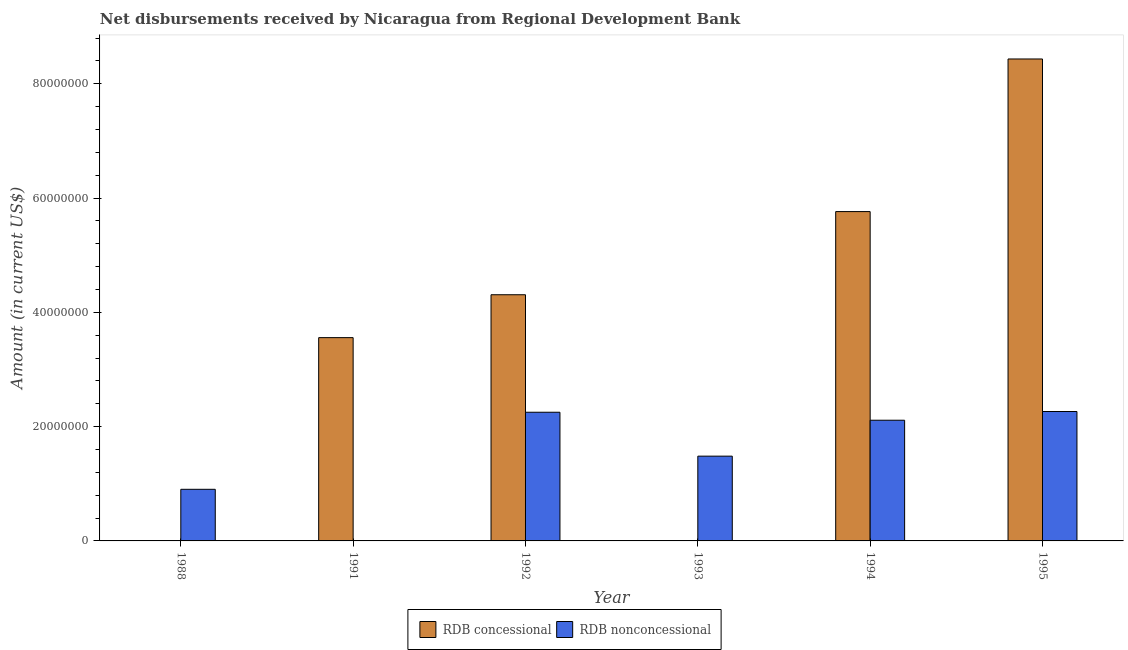How many different coloured bars are there?
Offer a very short reply. 2. Are the number of bars per tick equal to the number of legend labels?
Provide a succinct answer. No. Are the number of bars on each tick of the X-axis equal?
Your answer should be very brief. No. What is the label of the 5th group of bars from the left?
Keep it short and to the point. 1994. What is the net non concessional disbursements from rdb in 1993?
Keep it short and to the point. 1.48e+07. Across all years, what is the maximum net concessional disbursements from rdb?
Your answer should be very brief. 8.43e+07. In which year was the net non concessional disbursements from rdb maximum?
Offer a very short reply. 1995. What is the total net non concessional disbursements from rdb in the graph?
Give a very brief answer. 9.02e+07. What is the difference between the net non concessional disbursements from rdb in 1994 and that in 1995?
Give a very brief answer. -1.53e+06. What is the difference between the net non concessional disbursements from rdb in 1993 and the net concessional disbursements from rdb in 1992?
Give a very brief answer. -7.68e+06. What is the average net concessional disbursements from rdb per year?
Your response must be concise. 3.68e+07. In the year 1993, what is the difference between the net non concessional disbursements from rdb and net concessional disbursements from rdb?
Your answer should be compact. 0. What is the ratio of the net concessional disbursements from rdb in 1992 to that in 1995?
Provide a succinct answer. 0.51. Is the net non concessional disbursements from rdb in 1988 less than that in 1993?
Make the answer very short. Yes. What is the difference between the highest and the second highest net concessional disbursements from rdb?
Ensure brevity in your answer.  2.67e+07. What is the difference between the highest and the lowest net concessional disbursements from rdb?
Provide a short and direct response. 8.43e+07. In how many years, is the net non concessional disbursements from rdb greater than the average net non concessional disbursements from rdb taken over all years?
Make the answer very short. 3. How many bars are there?
Ensure brevity in your answer.  9. What is the difference between two consecutive major ticks on the Y-axis?
Ensure brevity in your answer.  2.00e+07. Are the values on the major ticks of Y-axis written in scientific E-notation?
Your answer should be very brief. No. Does the graph contain grids?
Your answer should be very brief. No. Where does the legend appear in the graph?
Offer a terse response. Bottom center. How are the legend labels stacked?
Make the answer very short. Horizontal. What is the title of the graph?
Make the answer very short. Net disbursements received by Nicaragua from Regional Development Bank. What is the label or title of the X-axis?
Provide a short and direct response. Year. What is the label or title of the Y-axis?
Your answer should be very brief. Amount (in current US$). What is the Amount (in current US$) of RDB concessional in 1988?
Ensure brevity in your answer.  0. What is the Amount (in current US$) of RDB nonconcessional in 1988?
Provide a succinct answer. 9.03e+06. What is the Amount (in current US$) in RDB concessional in 1991?
Give a very brief answer. 3.56e+07. What is the Amount (in current US$) of RDB nonconcessional in 1991?
Your answer should be compact. 0. What is the Amount (in current US$) of RDB concessional in 1992?
Your response must be concise. 4.31e+07. What is the Amount (in current US$) in RDB nonconcessional in 1992?
Your response must be concise. 2.25e+07. What is the Amount (in current US$) in RDB concessional in 1993?
Offer a very short reply. 0. What is the Amount (in current US$) in RDB nonconcessional in 1993?
Provide a succinct answer. 1.48e+07. What is the Amount (in current US$) of RDB concessional in 1994?
Provide a short and direct response. 5.76e+07. What is the Amount (in current US$) of RDB nonconcessional in 1994?
Your answer should be very brief. 2.11e+07. What is the Amount (in current US$) in RDB concessional in 1995?
Offer a terse response. 8.43e+07. What is the Amount (in current US$) in RDB nonconcessional in 1995?
Provide a short and direct response. 2.26e+07. Across all years, what is the maximum Amount (in current US$) of RDB concessional?
Offer a terse response. 8.43e+07. Across all years, what is the maximum Amount (in current US$) of RDB nonconcessional?
Give a very brief answer. 2.26e+07. What is the total Amount (in current US$) of RDB concessional in the graph?
Provide a short and direct response. 2.21e+08. What is the total Amount (in current US$) in RDB nonconcessional in the graph?
Keep it short and to the point. 9.02e+07. What is the difference between the Amount (in current US$) in RDB nonconcessional in 1988 and that in 1992?
Keep it short and to the point. -1.35e+07. What is the difference between the Amount (in current US$) of RDB nonconcessional in 1988 and that in 1993?
Give a very brief answer. -5.80e+06. What is the difference between the Amount (in current US$) of RDB nonconcessional in 1988 and that in 1994?
Offer a terse response. -1.21e+07. What is the difference between the Amount (in current US$) of RDB nonconcessional in 1988 and that in 1995?
Offer a very short reply. -1.36e+07. What is the difference between the Amount (in current US$) in RDB concessional in 1991 and that in 1992?
Your response must be concise. -7.50e+06. What is the difference between the Amount (in current US$) of RDB concessional in 1991 and that in 1994?
Your response must be concise. -2.21e+07. What is the difference between the Amount (in current US$) of RDB concessional in 1991 and that in 1995?
Your response must be concise. -4.88e+07. What is the difference between the Amount (in current US$) in RDB nonconcessional in 1992 and that in 1993?
Provide a succinct answer. 7.68e+06. What is the difference between the Amount (in current US$) in RDB concessional in 1992 and that in 1994?
Make the answer very short. -1.46e+07. What is the difference between the Amount (in current US$) in RDB nonconcessional in 1992 and that in 1994?
Your answer should be very brief. 1.40e+06. What is the difference between the Amount (in current US$) in RDB concessional in 1992 and that in 1995?
Offer a very short reply. -4.13e+07. What is the difference between the Amount (in current US$) of RDB nonconcessional in 1992 and that in 1995?
Your answer should be very brief. -1.28e+05. What is the difference between the Amount (in current US$) of RDB nonconcessional in 1993 and that in 1994?
Your response must be concise. -6.29e+06. What is the difference between the Amount (in current US$) of RDB nonconcessional in 1993 and that in 1995?
Provide a short and direct response. -7.81e+06. What is the difference between the Amount (in current US$) in RDB concessional in 1994 and that in 1995?
Your answer should be very brief. -2.67e+07. What is the difference between the Amount (in current US$) of RDB nonconcessional in 1994 and that in 1995?
Ensure brevity in your answer.  -1.53e+06. What is the difference between the Amount (in current US$) in RDB concessional in 1991 and the Amount (in current US$) in RDB nonconcessional in 1992?
Offer a very short reply. 1.31e+07. What is the difference between the Amount (in current US$) in RDB concessional in 1991 and the Amount (in current US$) in RDB nonconcessional in 1993?
Ensure brevity in your answer.  2.07e+07. What is the difference between the Amount (in current US$) in RDB concessional in 1991 and the Amount (in current US$) in RDB nonconcessional in 1994?
Provide a succinct answer. 1.45e+07. What is the difference between the Amount (in current US$) in RDB concessional in 1991 and the Amount (in current US$) in RDB nonconcessional in 1995?
Ensure brevity in your answer.  1.29e+07. What is the difference between the Amount (in current US$) of RDB concessional in 1992 and the Amount (in current US$) of RDB nonconcessional in 1993?
Give a very brief answer. 2.82e+07. What is the difference between the Amount (in current US$) of RDB concessional in 1992 and the Amount (in current US$) of RDB nonconcessional in 1994?
Your answer should be very brief. 2.20e+07. What is the difference between the Amount (in current US$) of RDB concessional in 1992 and the Amount (in current US$) of RDB nonconcessional in 1995?
Provide a succinct answer. 2.04e+07. What is the difference between the Amount (in current US$) in RDB concessional in 1994 and the Amount (in current US$) in RDB nonconcessional in 1995?
Ensure brevity in your answer.  3.50e+07. What is the average Amount (in current US$) in RDB concessional per year?
Your response must be concise. 3.68e+07. What is the average Amount (in current US$) in RDB nonconcessional per year?
Offer a terse response. 1.50e+07. In the year 1992, what is the difference between the Amount (in current US$) of RDB concessional and Amount (in current US$) of RDB nonconcessional?
Make the answer very short. 2.06e+07. In the year 1994, what is the difference between the Amount (in current US$) in RDB concessional and Amount (in current US$) in RDB nonconcessional?
Your answer should be compact. 3.65e+07. In the year 1995, what is the difference between the Amount (in current US$) of RDB concessional and Amount (in current US$) of RDB nonconcessional?
Make the answer very short. 6.17e+07. What is the ratio of the Amount (in current US$) in RDB nonconcessional in 1988 to that in 1992?
Offer a very short reply. 0.4. What is the ratio of the Amount (in current US$) in RDB nonconcessional in 1988 to that in 1993?
Ensure brevity in your answer.  0.61. What is the ratio of the Amount (in current US$) in RDB nonconcessional in 1988 to that in 1994?
Make the answer very short. 0.43. What is the ratio of the Amount (in current US$) in RDB nonconcessional in 1988 to that in 1995?
Provide a short and direct response. 0.4. What is the ratio of the Amount (in current US$) of RDB concessional in 1991 to that in 1992?
Keep it short and to the point. 0.83. What is the ratio of the Amount (in current US$) in RDB concessional in 1991 to that in 1994?
Keep it short and to the point. 0.62. What is the ratio of the Amount (in current US$) in RDB concessional in 1991 to that in 1995?
Ensure brevity in your answer.  0.42. What is the ratio of the Amount (in current US$) in RDB nonconcessional in 1992 to that in 1993?
Keep it short and to the point. 1.52. What is the ratio of the Amount (in current US$) of RDB concessional in 1992 to that in 1994?
Provide a short and direct response. 0.75. What is the ratio of the Amount (in current US$) of RDB nonconcessional in 1992 to that in 1994?
Your answer should be very brief. 1.07. What is the ratio of the Amount (in current US$) of RDB concessional in 1992 to that in 1995?
Your response must be concise. 0.51. What is the ratio of the Amount (in current US$) in RDB nonconcessional in 1992 to that in 1995?
Make the answer very short. 0.99. What is the ratio of the Amount (in current US$) of RDB nonconcessional in 1993 to that in 1994?
Provide a short and direct response. 0.7. What is the ratio of the Amount (in current US$) in RDB nonconcessional in 1993 to that in 1995?
Provide a short and direct response. 0.66. What is the ratio of the Amount (in current US$) of RDB concessional in 1994 to that in 1995?
Keep it short and to the point. 0.68. What is the ratio of the Amount (in current US$) in RDB nonconcessional in 1994 to that in 1995?
Give a very brief answer. 0.93. What is the difference between the highest and the second highest Amount (in current US$) in RDB concessional?
Provide a short and direct response. 2.67e+07. What is the difference between the highest and the second highest Amount (in current US$) in RDB nonconcessional?
Your answer should be compact. 1.28e+05. What is the difference between the highest and the lowest Amount (in current US$) of RDB concessional?
Keep it short and to the point. 8.43e+07. What is the difference between the highest and the lowest Amount (in current US$) of RDB nonconcessional?
Offer a very short reply. 2.26e+07. 